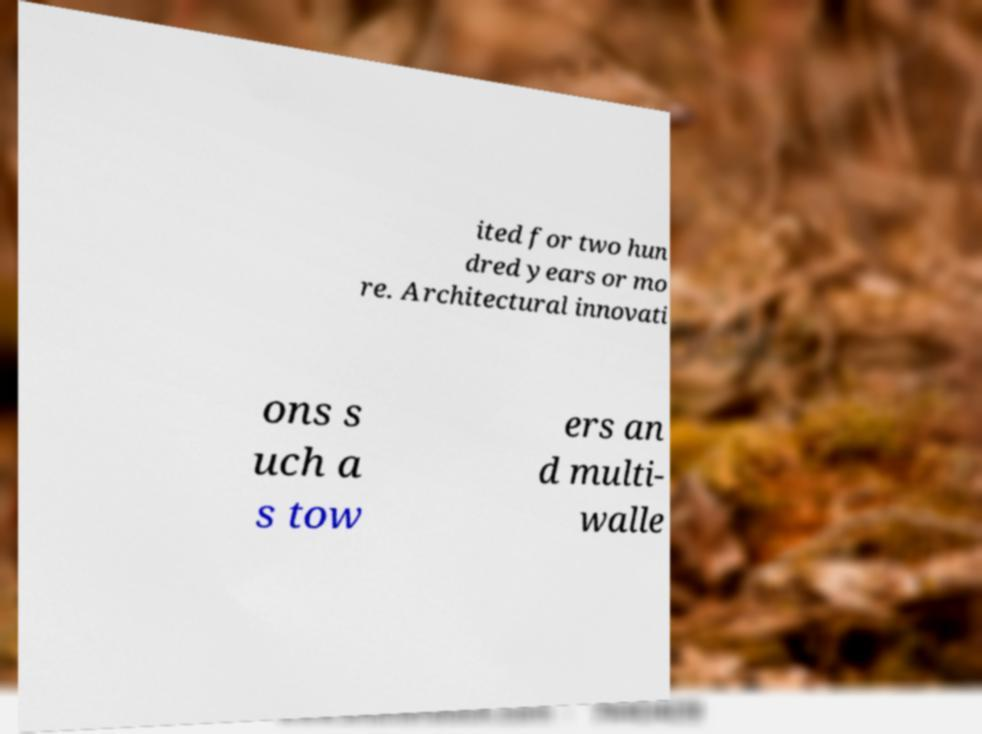Can you read and provide the text displayed in the image?This photo seems to have some interesting text. Can you extract and type it out for me? ited for two hun dred years or mo re. Architectural innovati ons s uch a s tow ers an d multi- walle 